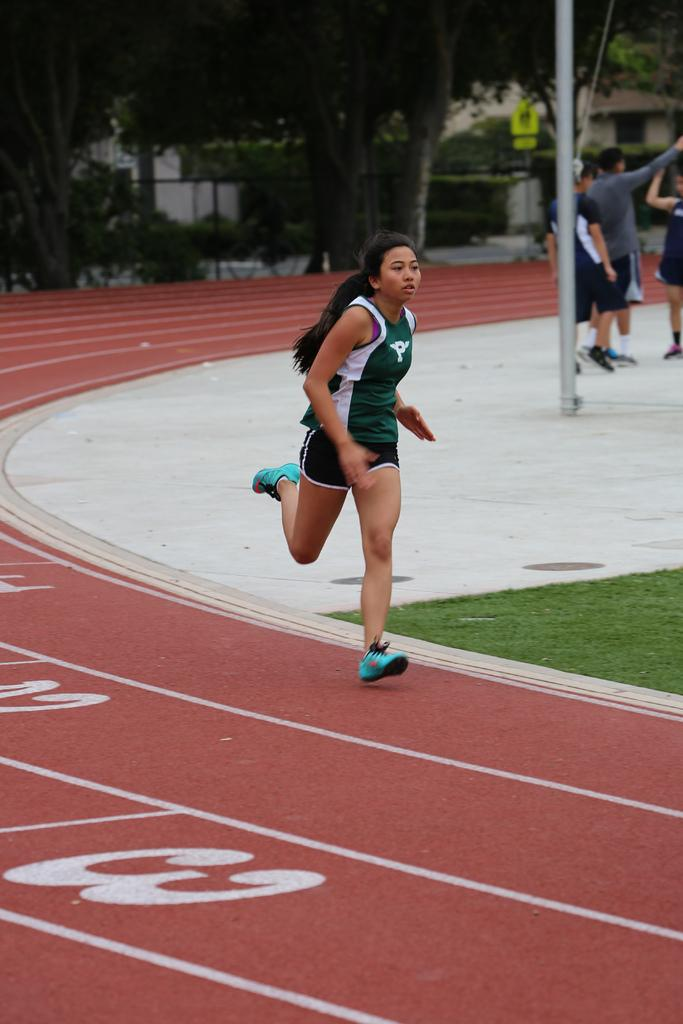<image>
Present a compact description of the photo's key features. Female runner standing next to the number 2 on the ground. 